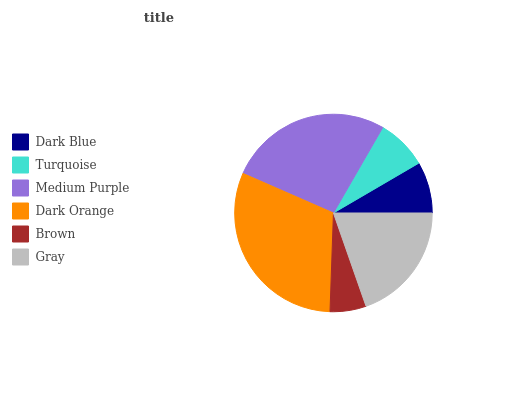Is Brown the minimum?
Answer yes or no. Yes. Is Dark Orange the maximum?
Answer yes or no. Yes. Is Turquoise the minimum?
Answer yes or no. No. Is Turquoise the maximum?
Answer yes or no. No. Is Dark Blue greater than Turquoise?
Answer yes or no. Yes. Is Turquoise less than Dark Blue?
Answer yes or no. Yes. Is Turquoise greater than Dark Blue?
Answer yes or no. No. Is Dark Blue less than Turquoise?
Answer yes or no. No. Is Gray the high median?
Answer yes or no. Yes. Is Dark Blue the low median?
Answer yes or no. Yes. Is Brown the high median?
Answer yes or no. No. Is Dark Orange the low median?
Answer yes or no. No. 